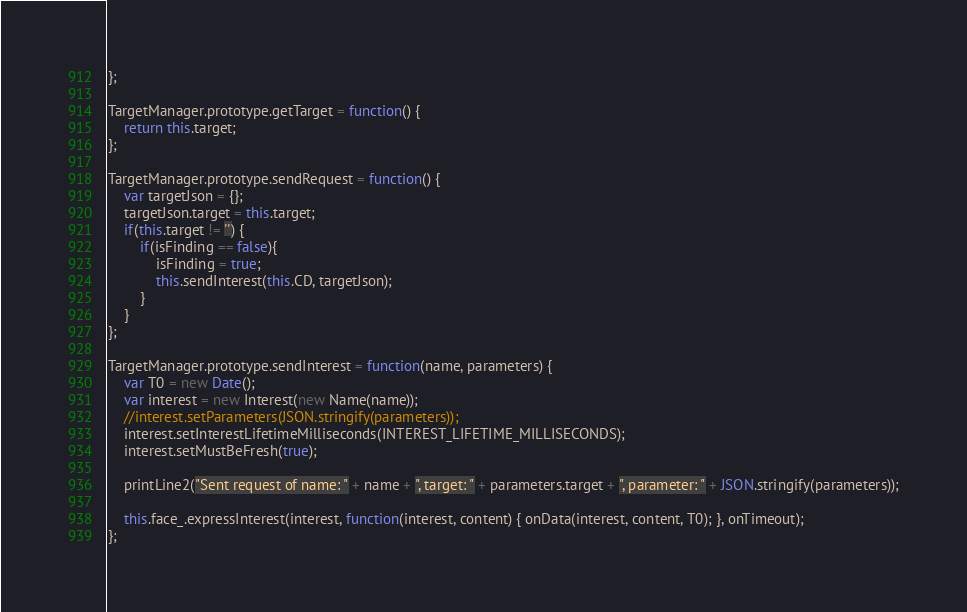Convert code to text. <code><loc_0><loc_0><loc_500><loc_500><_JavaScript_>};

TargetManager.prototype.getTarget = function() {
    return this.target;
};

TargetManager.prototype.sendRequest = function() {
    var targetJson = {};
    targetJson.target = this.target;
    if(this.target != '') {
        if(isFinding == false){
            isFinding = true;
            this.sendInterest(this.CD, targetJson);
        }
    }
};

TargetManager.prototype.sendInterest = function(name, parameters) {
    var T0 = new Date();
    var interest = new Interest(new Name(name));
    //interest.setParameters(JSON.stringify(parameters));
    interest.setInterestLifetimeMilliseconds(INTEREST_LIFETIME_MILLISECONDS);
    interest.setMustBeFresh(true);

    printLine2("Sent request of name: " + name + ", target: " + parameters.target + ", parameter: " + JSON.stringify(parameters));

    this.face_.expressInterest(interest, function(interest, content) { onData(interest, content, T0); }, onTimeout);
};
</code> 